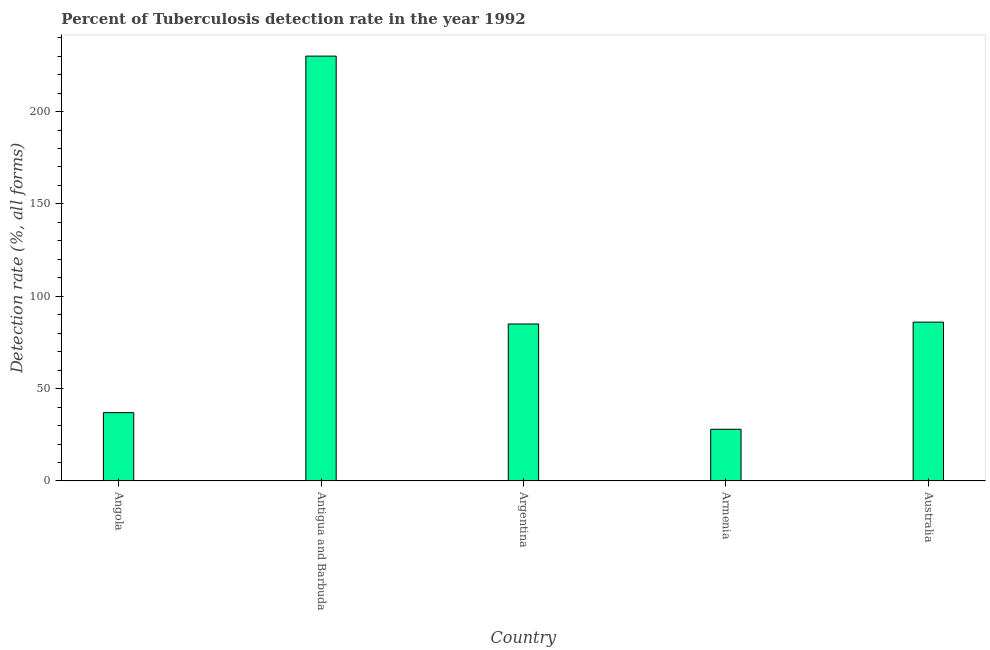Does the graph contain any zero values?
Provide a succinct answer. No. Does the graph contain grids?
Give a very brief answer. No. What is the title of the graph?
Your response must be concise. Percent of Tuberculosis detection rate in the year 1992. What is the label or title of the Y-axis?
Offer a terse response. Detection rate (%, all forms). Across all countries, what is the maximum detection rate of tuberculosis?
Provide a short and direct response. 230. Across all countries, what is the minimum detection rate of tuberculosis?
Your answer should be compact. 28. In which country was the detection rate of tuberculosis maximum?
Offer a terse response. Antigua and Barbuda. In which country was the detection rate of tuberculosis minimum?
Provide a succinct answer. Armenia. What is the sum of the detection rate of tuberculosis?
Keep it short and to the point. 466. What is the difference between the detection rate of tuberculosis in Angola and Antigua and Barbuda?
Provide a short and direct response. -193. What is the average detection rate of tuberculosis per country?
Provide a short and direct response. 93.2. What is the ratio of the detection rate of tuberculosis in Argentina to that in Australia?
Provide a short and direct response. 0.99. Is the difference between the detection rate of tuberculosis in Armenia and Australia greater than the difference between any two countries?
Provide a succinct answer. No. What is the difference between the highest and the second highest detection rate of tuberculosis?
Offer a very short reply. 144. Is the sum of the detection rate of tuberculosis in Antigua and Barbuda and Australia greater than the maximum detection rate of tuberculosis across all countries?
Offer a terse response. Yes. What is the difference between the highest and the lowest detection rate of tuberculosis?
Offer a very short reply. 202. In how many countries, is the detection rate of tuberculosis greater than the average detection rate of tuberculosis taken over all countries?
Your answer should be compact. 1. How many bars are there?
Your response must be concise. 5. Are all the bars in the graph horizontal?
Offer a terse response. No. How many countries are there in the graph?
Keep it short and to the point. 5. Are the values on the major ticks of Y-axis written in scientific E-notation?
Provide a succinct answer. No. What is the Detection rate (%, all forms) of Antigua and Barbuda?
Your answer should be compact. 230. What is the difference between the Detection rate (%, all forms) in Angola and Antigua and Barbuda?
Provide a short and direct response. -193. What is the difference between the Detection rate (%, all forms) in Angola and Argentina?
Offer a very short reply. -48. What is the difference between the Detection rate (%, all forms) in Angola and Australia?
Provide a short and direct response. -49. What is the difference between the Detection rate (%, all forms) in Antigua and Barbuda and Argentina?
Ensure brevity in your answer.  145. What is the difference between the Detection rate (%, all forms) in Antigua and Barbuda and Armenia?
Your response must be concise. 202. What is the difference between the Detection rate (%, all forms) in Antigua and Barbuda and Australia?
Provide a succinct answer. 144. What is the difference between the Detection rate (%, all forms) in Argentina and Armenia?
Your response must be concise. 57. What is the difference between the Detection rate (%, all forms) in Armenia and Australia?
Offer a terse response. -58. What is the ratio of the Detection rate (%, all forms) in Angola to that in Antigua and Barbuda?
Your response must be concise. 0.16. What is the ratio of the Detection rate (%, all forms) in Angola to that in Argentina?
Provide a succinct answer. 0.43. What is the ratio of the Detection rate (%, all forms) in Angola to that in Armenia?
Keep it short and to the point. 1.32. What is the ratio of the Detection rate (%, all forms) in Angola to that in Australia?
Keep it short and to the point. 0.43. What is the ratio of the Detection rate (%, all forms) in Antigua and Barbuda to that in Argentina?
Your response must be concise. 2.71. What is the ratio of the Detection rate (%, all forms) in Antigua and Barbuda to that in Armenia?
Offer a very short reply. 8.21. What is the ratio of the Detection rate (%, all forms) in Antigua and Barbuda to that in Australia?
Provide a succinct answer. 2.67. What is the ratio of the Detection rate (%, all forms) in Argentina to that in Armenia?
Ensure brevity in your answer.  3.04. What is the ratio of the Detection rate (%, all forms) in Argentina to that in Australia?
Make the answer very short. 0.99. What is the ratio of the Detection rate (%, all forms) in Armenia to that in Australia?
Offer a terse response. 0.33. 